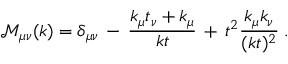Convert formula to latex. <formula><loc_0><loc_0><loc_500><loc_500>{ \mathcal { M } } _ { \mu \nu } ( k ) = \delta _ { \mu \nu } \, - \, \frac { k _ { \mu } t _ { \nu } + k _ { \mu } } { k t } \, + \, t ^ { 2 } \frac { k _ { \mu } k _ { \nu } } { ( k t ) ^ { 2 } } \, .</formula> 